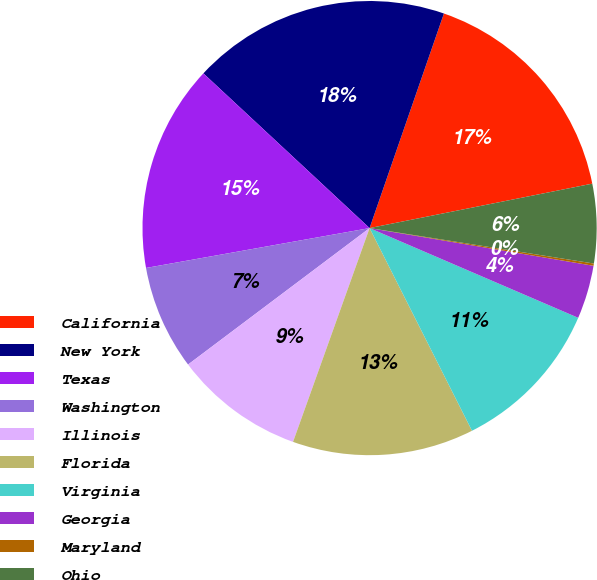<chart> <loc_0><loc_0><loc_500><loc_500><pie_chart><fcel>California<fcel>New York<fcel>Texas<fcel>Washington<fcel>Illinois<fcel>Florida<fcel>Virginia<fcel>Georgia<fcel>Maryland<fcel>Ohio<nl><fcel>16.56%<fcel>18.38%<fcel>14.74%<fcel>7.45%<fcel>9.27%<fcel>12.92%<fcel>11.09%<fcel>3.81%<fcel>0.16%<fcel>5.63%<nl></chart> 